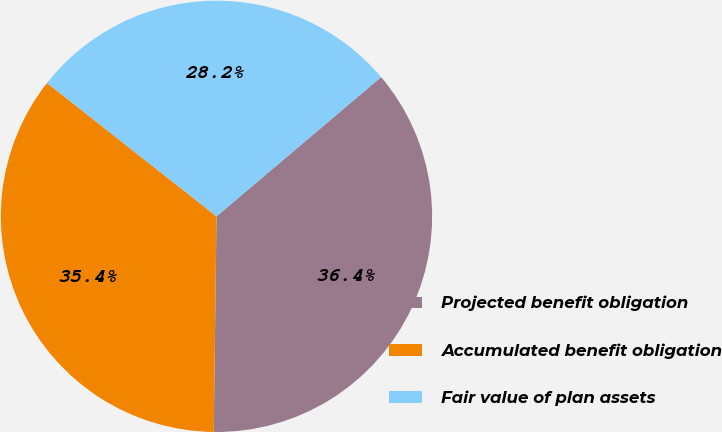Convert chart. <chart><loc_0><loc_0><loc_500><loc_500><pie_chart><fcel>Projected benefit obligation<fcel>Accumulated benefit obligation<fcel>Fair value of plan assets<nl><fcel>36.38%<fcel>35.41%<fcel>28.21%<nl></chart> 